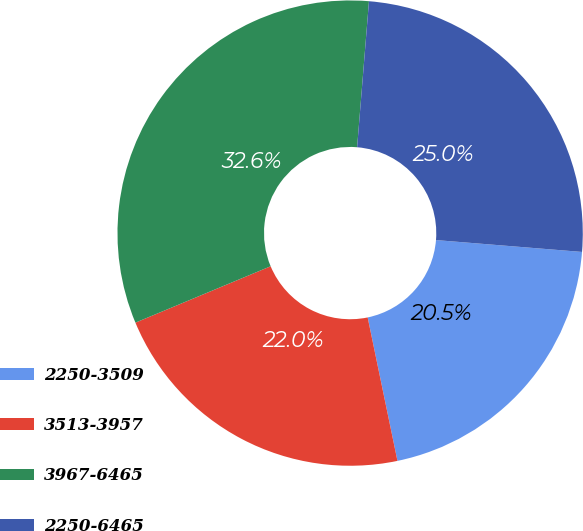Convert chart to OTSL. <chart><loc_0><loc_0><loc_500><loc_500><pie_chart><fcel>2250-3509<fcel>3513-3957<fcel>3967-6465<fcel>2250-6465<nl><fcel>20.45%<fcel>21.97%<fcel>32.58%<fcel>25.0%<nl></chart> 